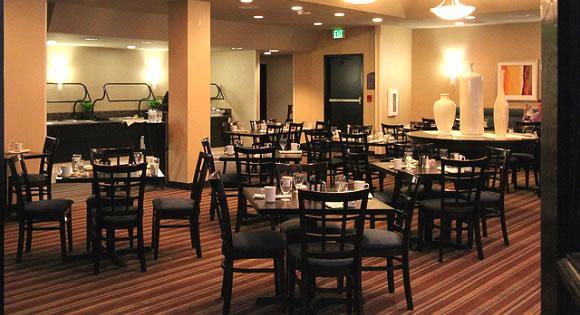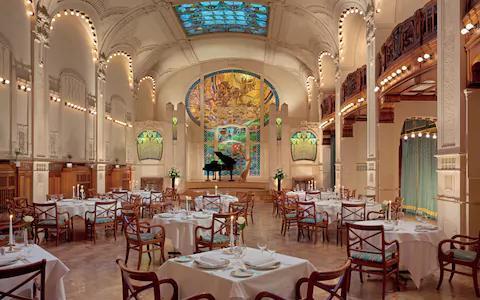The first image is the image on the left, the second image is the image on the right. Analyze the images presented: Is the assertion "Tables are set in an unoccupied dining area in each of the images." valid? Answer yes or no. Yes. The first image is the image on the left, the second image is the image on the right. Given the left and right images, does the statement "In one image, a grand piano is at the far end of a room where many tables are set for dinner." hold true? Answer yes or no. Yes. 